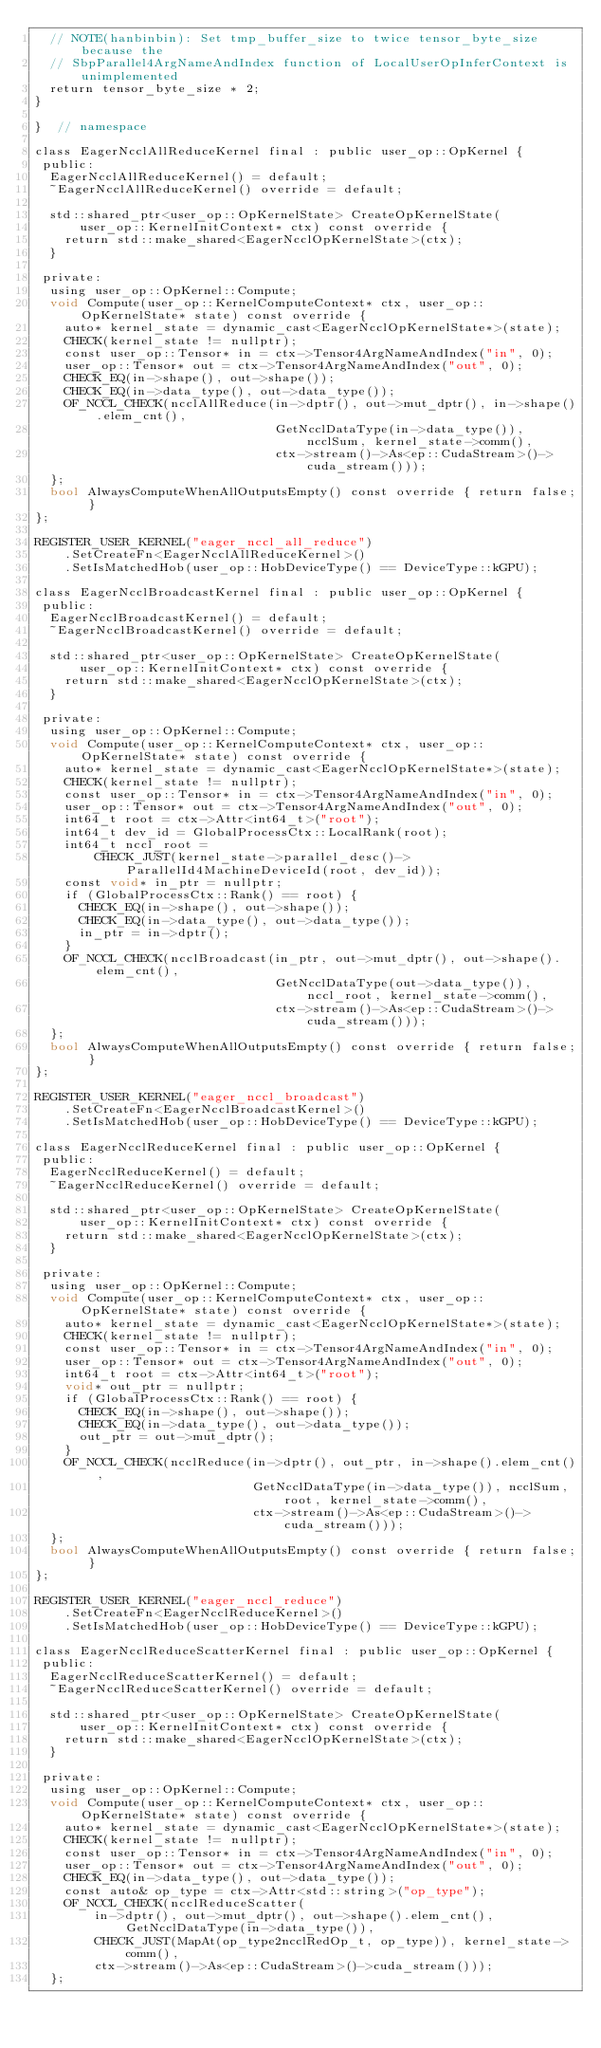Convert code to text. <code><loc_0><loc_0><loc_500><loc_500><_Cuda_>  // NOTE(hanbinbin): Set tmp_buffer_size to twice tensor_byte_size because the
  // SbpParallel4ArgNameAndIndex function of LocalUserOpInferContext is unimplemented
  return tensor_byte_size * 2;
}

}  // namespace

class EagerNcclAllReduceKernel final : public user_op::OpKernel {
 public:
  EagerNcclAllReduceKernel() = default;
  ~EagerNcclAllReduceKernel() override = default;

  std::shared_ptr<user_op::OpKernelState> CreateOpKernelState(
      user_op::KernelInitContext* ctx) const override {
    return std::make_shared<EagerNcclOpKernelState>(ctx);
  }

 private:
  using user_op::OpKernel::Compute;
  void Compute(user_op::KernelComputeContext* ctx, user_op::OpKernelState* state) const override {
    auto* kernel_state = dynamic_cast<EagerNcclOpKernelState*>(state);
    CHECK(kernel_state != nullptr);
    const user_op::Tensor* in = ctx->Tensor4ArgNameAndIndex("in", 0);
    user_op::Tensor* out = ctx->Tensor4ArgNameAndIndex("out", 0);
    CHECK_EQ(in->shape(), out->shape());
    CHECK_EQ(in->data_type(), out->data_type());
    OF_NCCL_CHECK(ncclAllReduce(in->dptr(), out->mut_dptr(), in->shape().elem_cnt(),
                                GetNcclDataType(in->data_type()), ncclSum, kernel_state->comm(),
                                ctx->stream()->As<ep::CudaStream>()->cuda_stream()));
  };
  bool AlwaysComputeWhenAllOutputsEmpty() const override { return false; }
};

REGISTER_USER_KERNEL("eager_nccl_all_reduce")
    .SetCreateFn<EagerNcclAllReduceKernel>()
    .SetIsMatchedHob(user_op::HobDeviceType() == DeviceType::kGPU);

class EagerNcclBroadcastKernel final : public user_op::OpKernel {
 public:
  EagerNcclBroadcastKernel() = default;
  ~EagerNcclBroadcastKernel() override = default;

  std::shared_ptr<user_op::OpKernelState> CreateOpKernelState(
      user_op::KernelInitContext* ctx) const override {
    return std::make_shared<EagerNcclOpKernelState>(ctx);
  }

 private:
  using user_op::OpKernel::Compute;
  void Compute(user_op::KernelComputeContext* ctx, user_op::OpKernelState* state) const override {
    auto* kernel_state = dynamic_cast<EagerNcclOpKernelState*>(state);
    CHECK(kernel_state != nullptr);
    const user_op::Tensor* in = ctx->Tensor4ArgNameAndIndex("in", 0);
    user_op::Tensor* out = ctx->Tensor4ArgNameAndIndex("out", 0);
    int64_t root = ctx->Attr<int64_t>("root");
    int64_t dev_id = GlobalProcessCtx::LocalRank(root);
    int64_t nccl_root =
        CHECK_JUST(kernel_state->parallel_desc()->ParallelId4MachineDeviceId(root, dev_id));
    const void* in_ptr = nullptr;
    if (GlobalProcessCtx::Rank() == root) {
      CHECK_EQ(in->shape(), out->shape());
      CHECK_EQ(in->data_type(), out->data_type());
      in_ptr = in->dptr();
    }
    OF_NCCL_CHECK(ncclBroadcast(in_ptr, out->mut_dptr(), out->shape().elem_cnt(),
                                GetNcclDataType(out->data_type()), nccl_root, kernel_state->comm(),
                                ctx->stream()->As<ep::CudaStream>()->cuda_stream()));
  };
  bool AlwaysComputeWhenAllOutputsEmpty() const override { return false; }
};

REGISTER_USER_KERNEL("eager_nccl_broadcast")
    .SetCreateFn<EagerNcclBroadcastKernel>()
    .SetIsMatchedHob(user_op::HobDeviceType() == DeviceType::kGPU);

class EagerNcclReduceKernel final : public user_op::OpKernel {
 public:
  EagerNcclReduceKernel() = default;
  ~EagerNcclReduceKernel() override = default;

  std::shared_ptr<user_op::OpKernelState> CreateOpKernelState(
      user_op::KernelInitContext* ctx) const override {
    return std::make_shared<EagerNcclOpKernelState>(ctx);
  }

 private:
  using user_op::OpKernel::Compute;
  void Compute(user_op::KernelComputeContext* ctx, user_op::OpKernelState* state) const override {
    auto* kernel_state = dynamic_cast<EagerNcclOpKernelState*>(state);
    CHECK(kernel_state != nullptr);
    const user_op::Tensor* in = ctx->Tensor4ArgNameAndIndex("in", 0);
    user_op::Tensor* out = ctx->Tensor4ArgNameAndIndex("out", 0);
    int64_t root = ctx->Attr<int64_t>("root");
    void* out_ptr = nullptr;
    if (GlobalProcessCtx::Rank() == root) {
      CHECK_EQ(in->shape(), out->shape());
      CHECK_EQ(in->data_type(), out->data_type());
      out_ptr = out->mut_dptr();
    }
    OF_NCCL_CHECK(ncclReduce(in->dptr(), out_ptr, in->shape().elem_cnt(),
                             GetNcclDataType(in->data_type()), ncclSum, root, kernel_state->comm(),
                             ctx->stream()->As<ep::CudaStream>()->cuda_stream()));
  };
  bool AlwaysComputeWhenAllOutputsEmpty() const override { return false; }
};

REGISTER_USER_KERNEL("eager_nccl_reduce")
    .SetCreateFn<EagerNcclReduceKernel>()
    .SetIsMatchedHob(user_op::HobDeviceType() == DeviceType::kGPU);

class EagerNcclReduceScatterKernel final : public user_op::OpKernel {
 public:
  EagerNcclReduceScatterKernel() = default;
  ~EagerNcclReduceScatterKernel() override = default;

  std::shared_ptr<user_op::OpKernelState> CreateOpKernelState(
      user_op::KernelInitContext* ctx) const override {
    return std::make_shared<EagerNcclOpKernelState>(ctx);
  }

 private:
  using user_op::OpKernel::Compute;
  void Compute(user_op::KernelComputeContext* ctx, user_op::OpKernelState* state) const override {
    auto* kernel_state = dynamic_cast<EagerNcclOpKernelState*>(state);
    CHECK(kernel_state != nullptr);
    const user_op::Tensor* in = ctx->Tensor4ArgNameAndIndex("in", 0);
    user_op::Tensor* out = ctx->Tensor4ArgNameAndIndex("out", 0);
    CHECK_EQ(in->data_type(), out->data_type());
    const auto& op_type = ctx->Attr<std::string>("op_type");
    OF_NCCL_CHECK(ncclReduceScatter(
        in->dptr(), out->mut_dptr(), out->shape().elem_cnt(), GetNcclDataType(in->data_type()),
        CHECK_JUST(MapAt(op_type2ncclRedOp_t, op_type)), kernel_state->comm(),
        ctx->stream()->As<ep::CudaStream>()->cuda_stream()));
  };</code> 